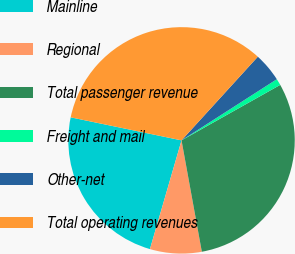<chart> <loc_0><loc_0><loc_500><loc_500><pie_chart><fcel>Mainline<fcel>Regional<fcel>Total passenger revenue<fcel>Freight and mail<fcel>Other-net<fcel>Total operating revenues<nl><fcel>23.76%<fcel>7.37%<fcel>30.28%<fcel>0.93%<fcel>4.15%<fcel>33.5%<nl></chart> 